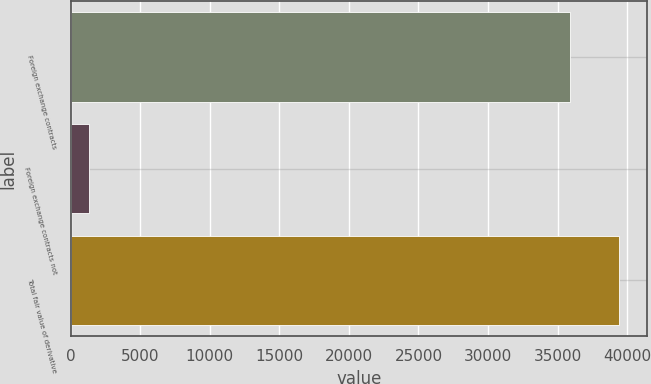<chart> <loc_0><loc_0><loc_500><loc_500><bar_chart><fcel>Foreign exchange contracts<fcel>Foreign exchange contracts not<fcel>Total fair value of derivative<nl><fcel>35853<fcel>1343<fcel>39438.3<nl></chart> 